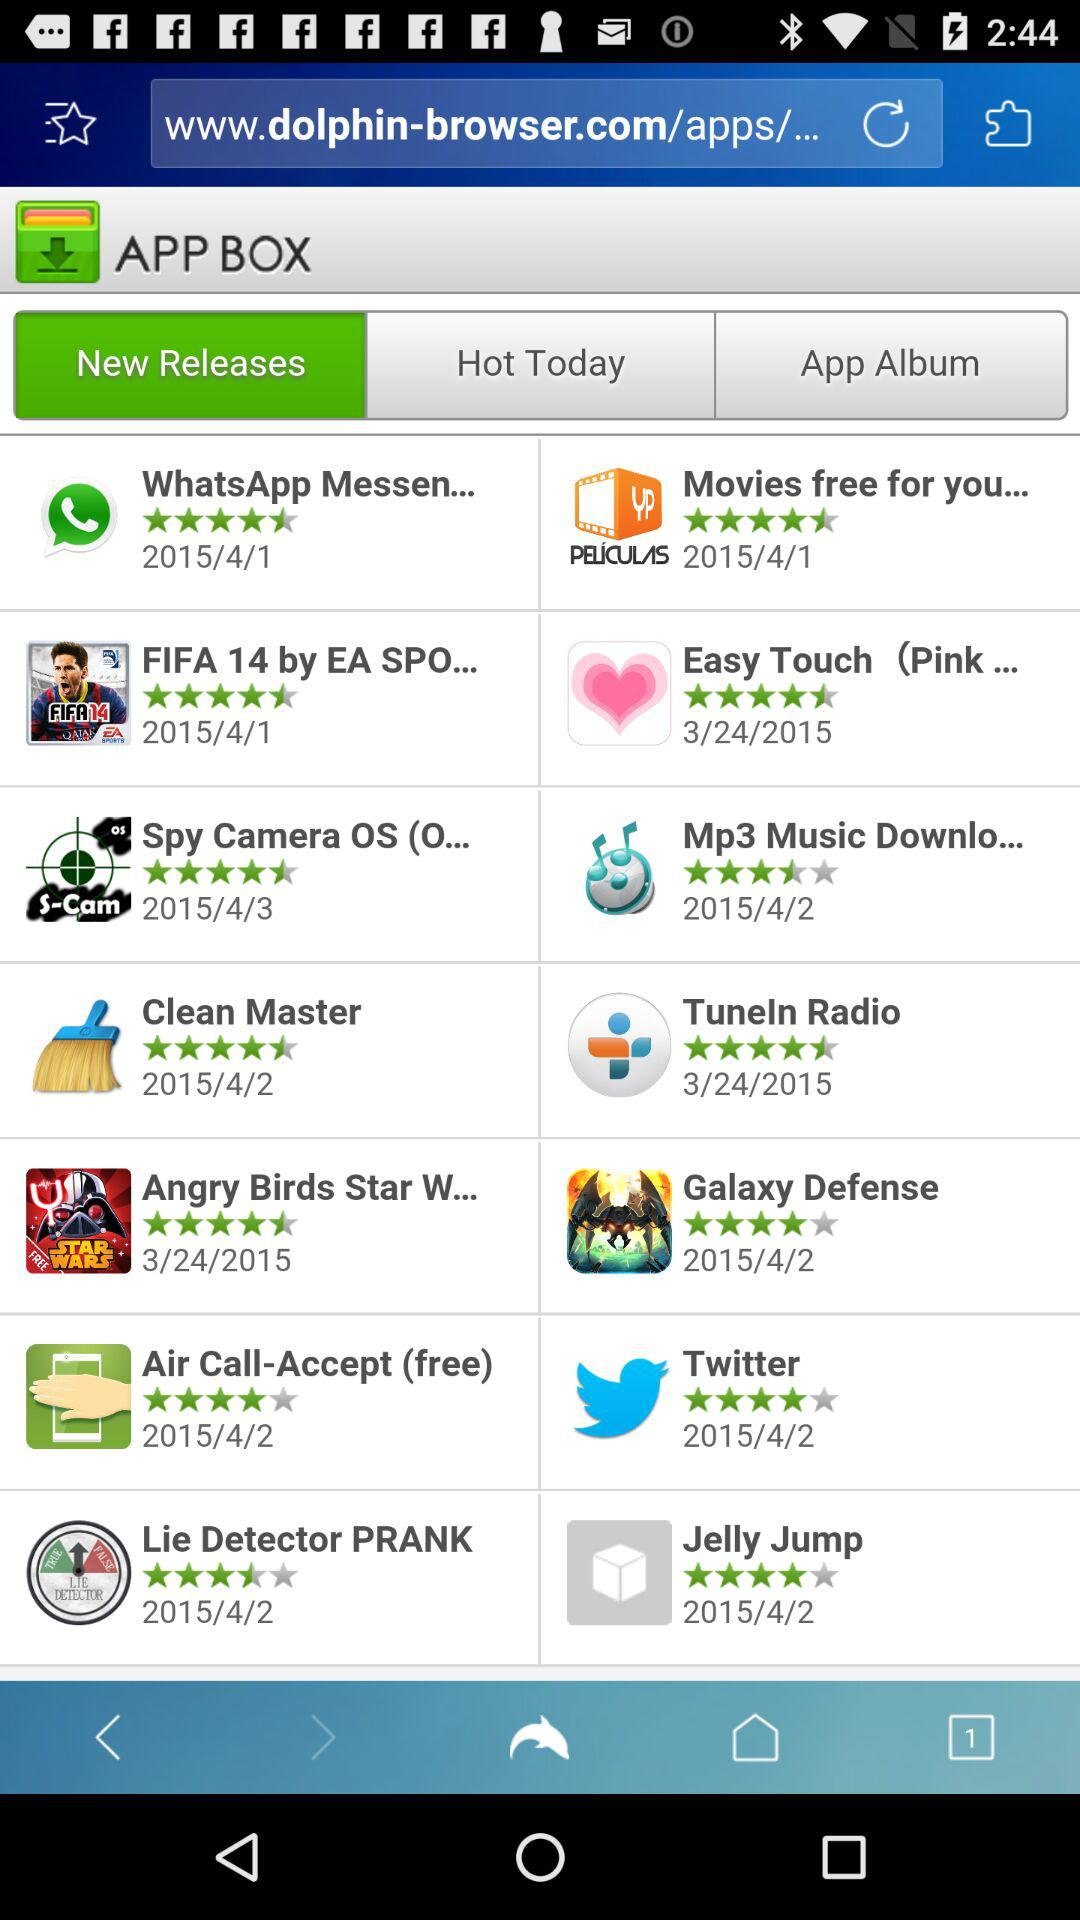Which tab is selected in the "APP BOX"? The selected tab is "New Releases". 